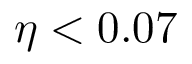<formula> <loc_0><loc_0><loc_500><loc_500>\eta < 0 . 0 7</formula> 